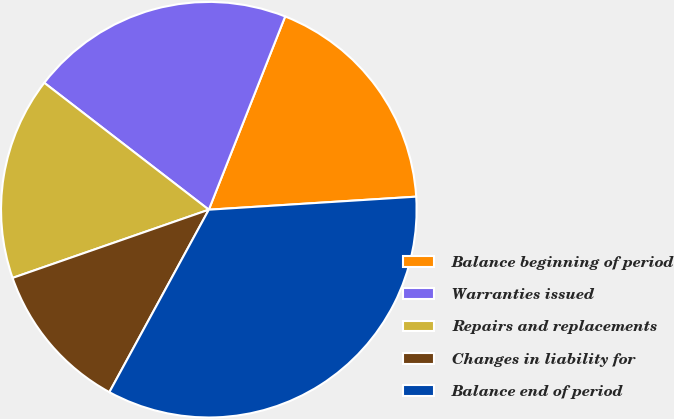Convert chart. <chart><loc_0><loc_0><loc_500><loc_500><pie_chart><fcel>Balance beginning of period<fcel>Warranties issued<fcel>Repairs and replacements<fcel>Changes in liability for<fcel>Balance end of period<nl><fcel>18.01%<fcel>20.53%<fcel>15.78%<fcel>11.73%<fcel>33.94%<nl></chart> 